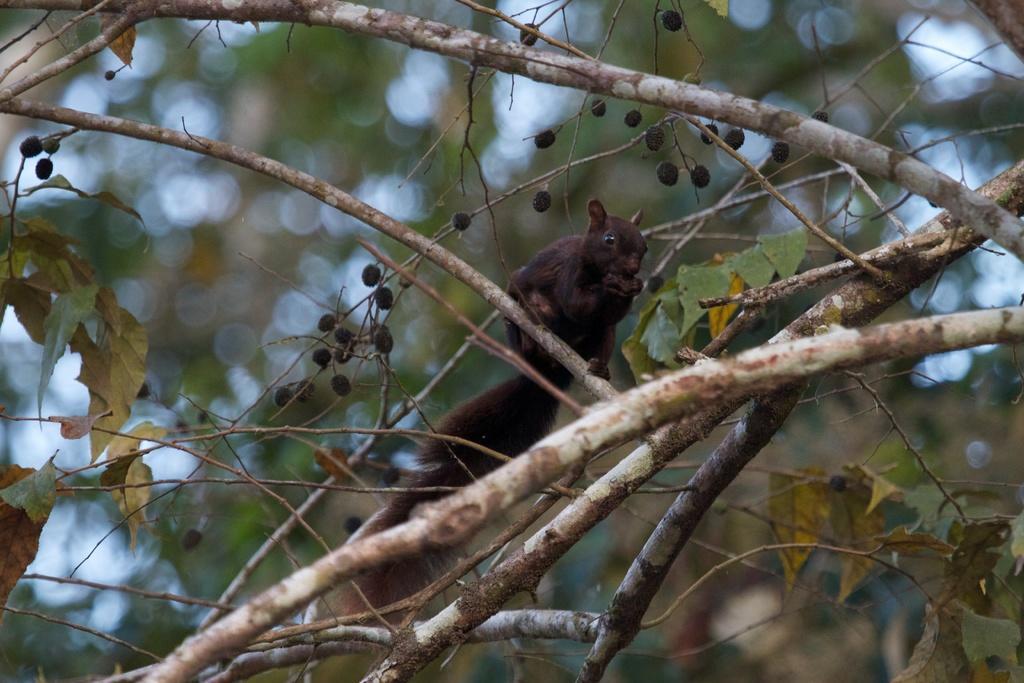How would you summarize this image in a sentence or two? In this picture we can see a squirrel on the tree branch and in the background we can see trees it is blurry. 